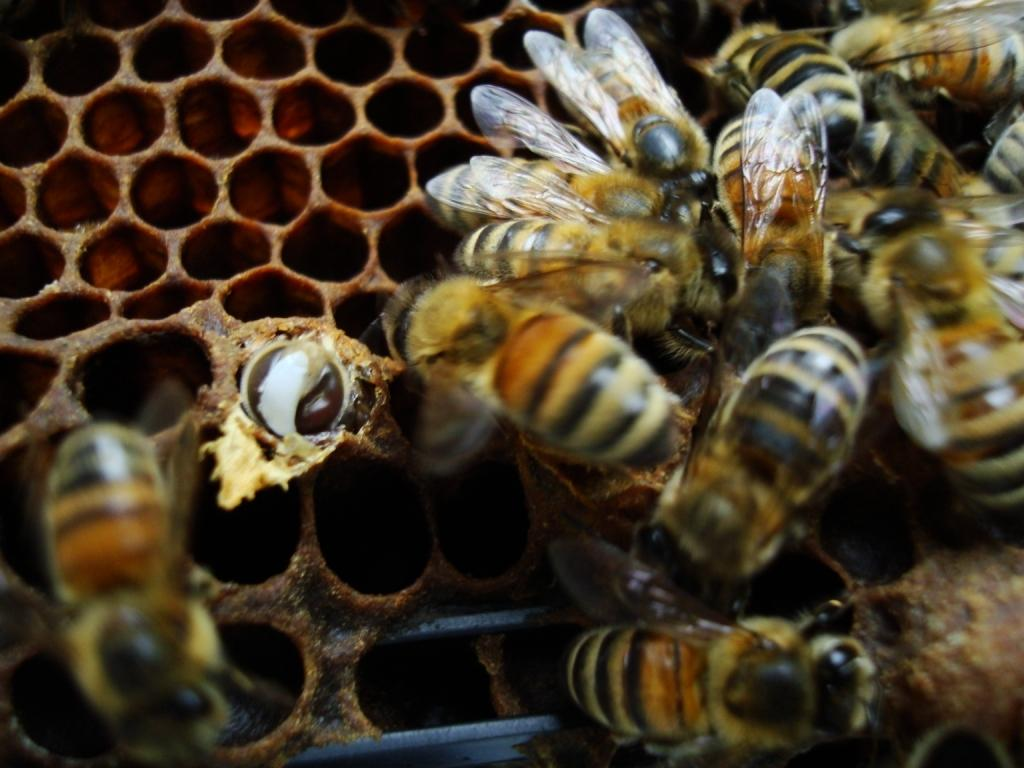What type of insects are present in the image? There are honey bees in the image. Where are the honey bees located? The honey bees are on a nest. What type of expansion is the honey bee nest undergoing in the image? There is no indication of any expansion in the image; it simply shows honey bees on a nest. How many sisters can be seen among the honey bees in the image? Honey bees are all female, but the image does not allow us to identify individual bees or their relationships, so we cannot determine the number of sisters among them. 